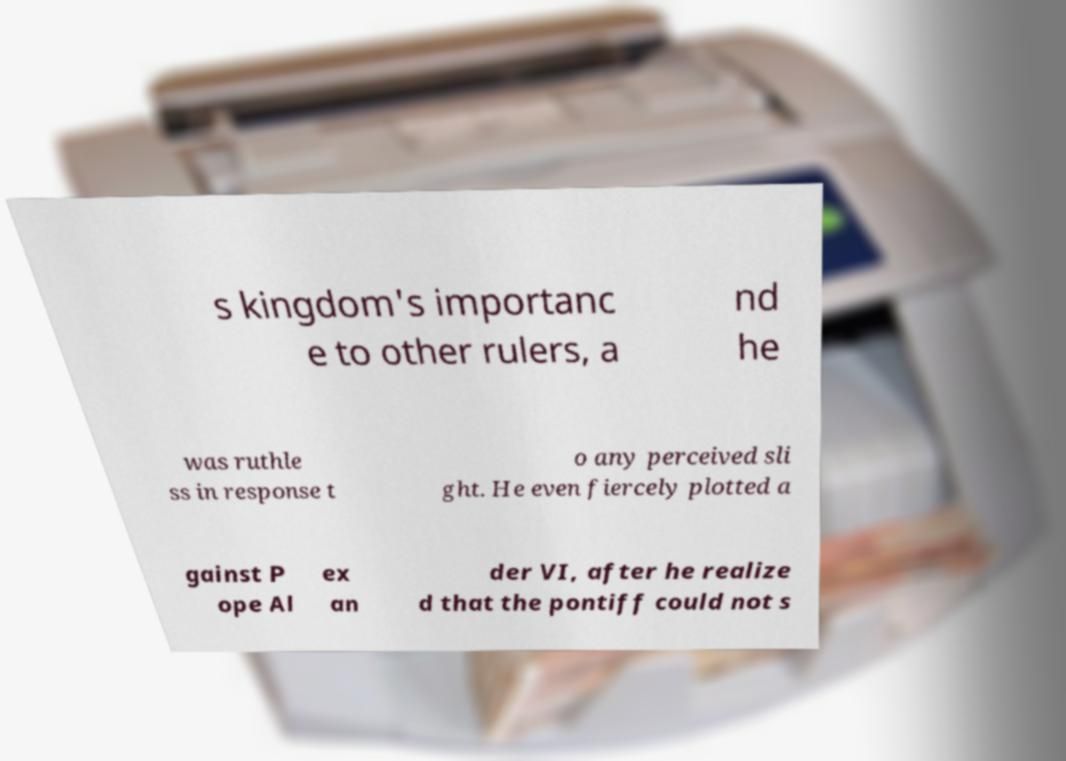Can you accurately transcribe the text from the provided image for me? s kingdom's importanc e to other rulers, a nd he was ruthle ss in response t o any perceived sli ght. He even fiercely plotted a gainst P ope Al ex an der VI, after he realize d that the pontiff could not s 